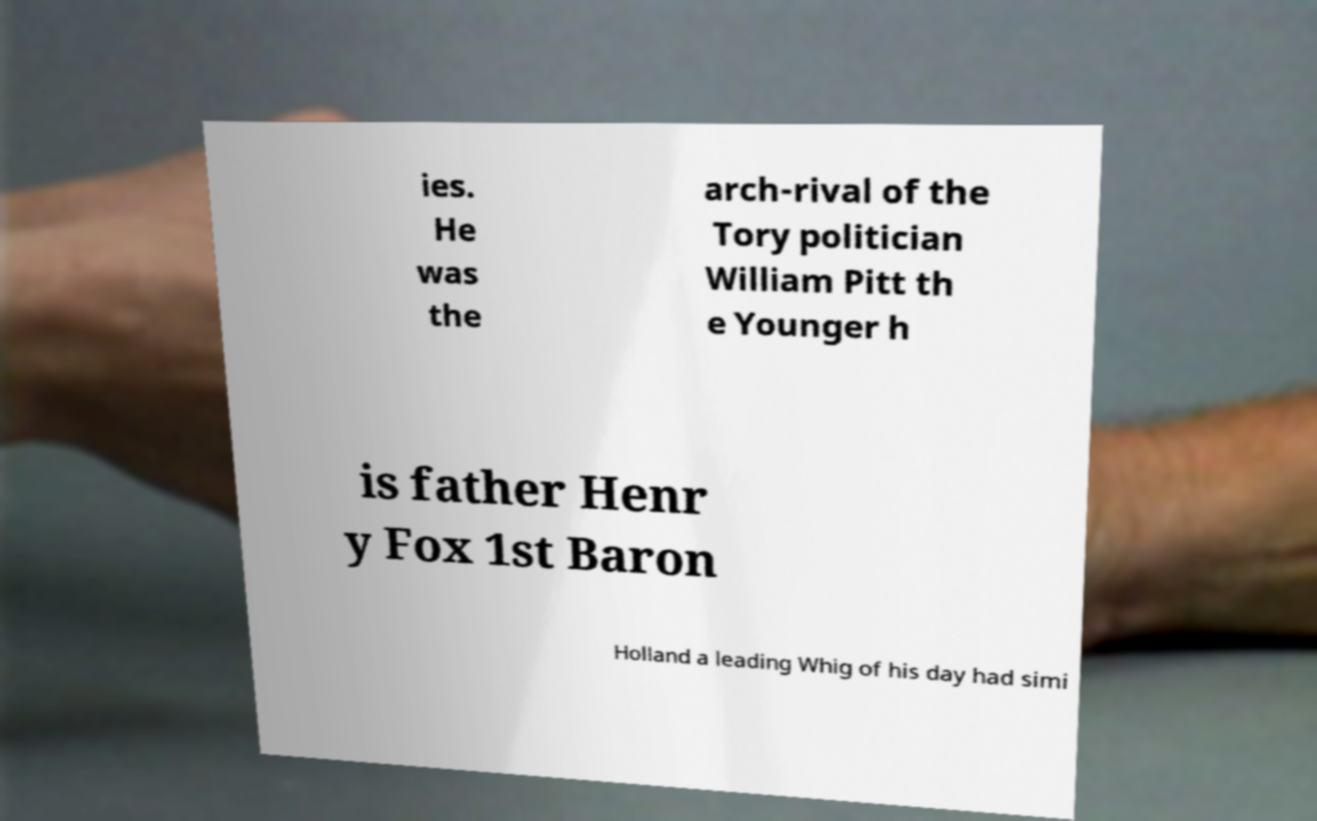I need the written content from this picture converted into text. Can you do that? ies. He was the arch-rival of the Tory politician William Pitt th e Younger h is father Henr y Fox 1st Baron Holland a leading Whig of his day had simi 